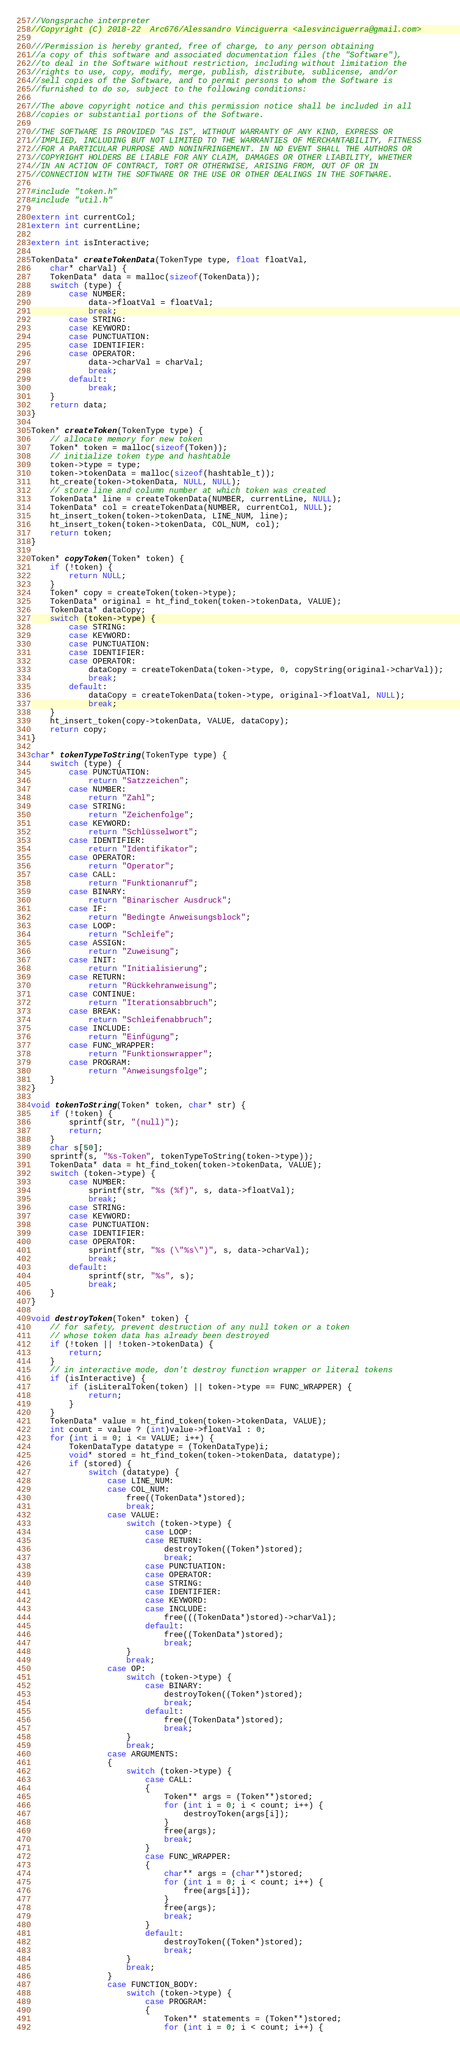Convert code to text. <code><loc_0><loc_0><loc_500><loc_500><_C_>//Vongsprache interpreter
//Copyright (C) 2018-22  Arc676/Alessandro Vinciguerra <alesvinciguerra@gmail.com>

///Permission is hereby granted, free of charge, to any person obtaining
//a copy of this software and associated documentation files (the "Software"),
//to deal in the Software without restriction, including without limitation the
//rights to use, copy, modify, merge, publish, distribute, sublicense, and/or
//sell copies of the Software, and to permit persons to whom the Software is
//furnished to do so, subject to the following conditions:

//The above copyright notice and this permission notice shall be included in all
//copies or substantial portions of the Software.

//THE SOFTWARE IS PROVIDED "AS IS", WITHOUT WARRANTY OF ANY KIND, EXPRESS OR
//IMPLIED, INCLUDING BUT NOT LIMITED TO THE WARRANTIES OF MERCHANTABILITY, FITNESS
//FOR A PARTICULAR PURPOSE AND NONINFRINGEMENT. IN NO EVENT SHALL THE AUTHORS OR
//COPYRIGHT HOLDERS BE LIABLE FOR ANY CLAIM, DAMAGES OR OTHER LIABILITY, WHETHER
//IN AN ACTION OF CONTRACT, TORT OR OTHERWISE, ARISING FROM, OUT OF OR IN
//CONNECTION WITH THE SOFTWARE OR THE USE OR OTHER DEALINGS IN THE SOFTWARE.

#include "token.h"
#include "util.h"

extern int currentCol;
extern int currentLine;

extern int isInteractive;

TokenData* createTokenData(TokenType type, float floatVal,
	char* charVal) {
	TokenData* data = malloc(sizeof(TokenData));
	switch (type) {
		case NUMBER:
			data->floatVal = floatVal;
			break;
		case STRING:
		case KEYWORD:
		case PUNCTUATION:
		case IDENTIFIER:
		case OPERATOR:
			data->charVal = charVal;
			break;
		default:
			break;
	}
	return data;
}

Token* createToken(TokenType type) {
	// allocate memory for new token
	Token* token = malloc(sizeof(Token));
	// initialize token type and hashtable
	token->type = type;
	token->tokenData = malloc(sizeof(hashtable_t));
	ht_create(token->tokenData, NULL, NULL);
	// store line and column number at which token was created
	TokenData* line = createTokenData(NUMBER, currentLine, NULL);
	TokenData* col = createTokenData(NUMBER, currentCol, NULL);
	ht_insert_token(token->tokenData, LINE_NUM, line);
	ht_insert_token(token->tokenData, COL_NUM, col);
	return token;
}

Token* copyToken(Token* token) {
	if (!token) {
		return NULL;
	}
	Token* copy = createToken(token->type);
	TokenData* original = ht_find_token(token->tokenData, VALUE);
	TokenData* dataCopy;
	switch (token->type) {
		case STRING:
		case KEYWORD:
		case PUNCTUATION:
		case IDENTIFIER:
		case OPERATOR:
			dataCopy = createTokenData(token->type, 0, copyString(original->charVal));
			break;
		default:
			dataCopy = createTokenData(token->type, original->floatVal, NULL);
			break;
	}
	ht_insert_token(copy->tokenData, VALUE, dataCopy);
	return copy;
}

char* tokenTypeToString(TokenType type) {
	switch (type) {
		case PUNCTUATION:
			return "Satzzeichen";
		case NUMBER:
			return "Zahl";
		case STRING:
			return "Zeichenfolge";
		case KEYWORD:
			return "Schlüsselwort";
		case IDENTIFIER:
			return "Identifikator";
		case OPERATOR:
			return "Operator";
		case CALL:
			return "Funktionanruf";
		case BINARY:
			return "Binarischer Ausdruck";
		case IF:
			return "Bedingte Anweisungsblock";
		case LOOP:
			return "Schleife";
		case ASSIGN:
			return "Zuweisung";
		case INIT:
			return "Initialisierung";
		case RETURN:
			return "Rückkehranweisung";
		case CONTINUE:
			return "Iterationsabbruch";
		case BREAK:
			return "Schleifenabbruch";
		case INCLUDE:
			return "Einfügung";
		case FUNC_WRAPPER:
			return "Funktionswrapper";
		case PROGRAM:
			return "Anweisungsfolge";
	}
}

void tokenToString(Token* token, char* str) {
	if (!token) {
		sprintf(str, "(null)");
		return;
	}
	char s[50];
	sprintf(s, "%s-Token", tokenTypeToString(token->type));
	TokenData* data = ht_find_token(token->tokenData, VALUE);
	switch (token->type) {
		case NUMBER:
			sprintf(str, "%s (%f)", s, data->floatVal);
			break;
		case STRING:
		case KEYWORD:
		case PUNCTUATION:
		case IDENTIFIER:
		case OPERATOR:
			sprintf(str, "%s (\"%s\")", s, data->charVal);
			break;
		default:
			sprintf(str, "%s", s);
			break;
	}
}

void destroyToken(Token* token) {
	// for safety, prevent destruction of any null token or a token
	// whose token data has already been destroyed
	if (!token || !token->tokenData) {
		return;
	}
	// in interactive mode, don't destroy function wrapper or literal tokens
	if (isInteractive) {
		if (isLiteralToken(token) || token->type == FUNC_WRAPPER) {
			return;
		}
	}
	TokenData* value = ht_find_token(token->tokenData, VALUE);
	int count = value ? (int)value->floatVal : 0;
	for (int i = 0; i <= VALUE; i++) {
		TokenDataType datatype = (TokenDataType)i;
		void* stored = ht_find_token(token->tokenData, datatype);
		if (stored) {
			switch (datatype) {
				case LINE_NUM:
				case COL_NUM:
					free((TokenData*)stored);
					break;
				case VALUE:
					switch (token->type) {
						case LOOP:
						case RETURN:
							destroyToken((Token*)stored);
							break;
						case PUNCTUATION:
						case OPERATOR:
						case STRING:
						case IDENTIFIER:
						case KEYWORD:
						case INCLUDE:
							free(((TokenData*)stored)->charVal);
						default:
							free((TokenData*)stored);
							break;
					}
					break;
				case OP:
					switch (token->type) {
						case BINARY:
							destroyToken((Token*)stored);
							break;
						default:
							free((TokenData*)stored);
							break;
					}
					break;
				case ARGUMENTS:
				{
					switch (token->type) {
						case CALL:
						{
							Token** args = (Token**)stored;
							for (int i = 0; i < count; i++) {
								destroyToken(args[i]);
							}
							free(args);
							break;
						}
						case FUNC_WRAPPER:
						{
							char** args = (char**)stored;
							for (int i = 0; i < count; i++) {
								free(args[i]);
							}
							free(args);
							break;
						}
						default:
							destroyToken((Token*)stored);
							break;
					}
					break;
				}
				case FUNCTION_BODY:
					switch (token->type) {
						case PROGRAM:
						{
							Token** statements = (Token**)stored;
							for (int i = 0; i < count; i++) {</code> 